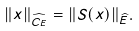<formula> <loc_0><loc_0><loc_500><loc_500>\| x \| _ { \widehat { C _ { E } } } = \| S ( x ) \| _ { \widehat { E } } .</formula> 